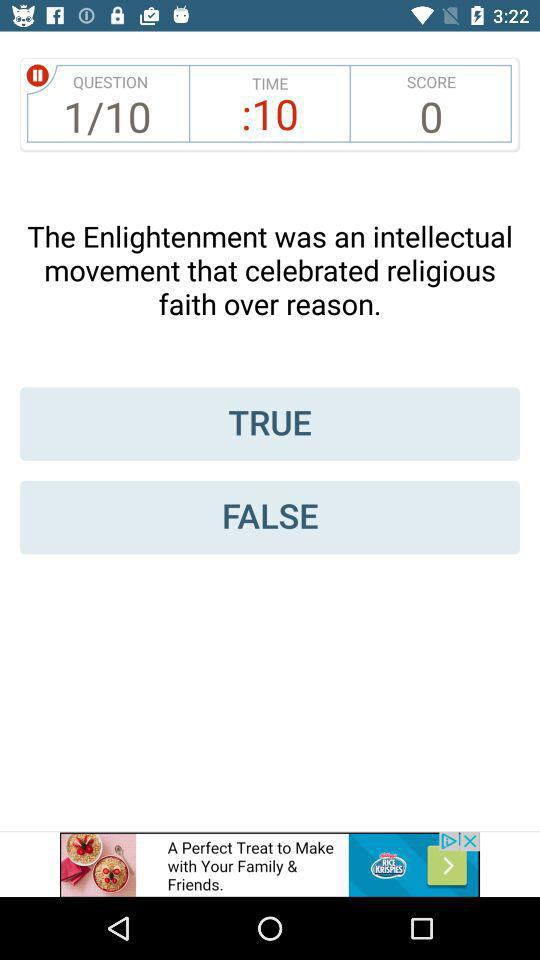How many seconds are left on the timer?
Answer the question using a single word or phrase. 10 